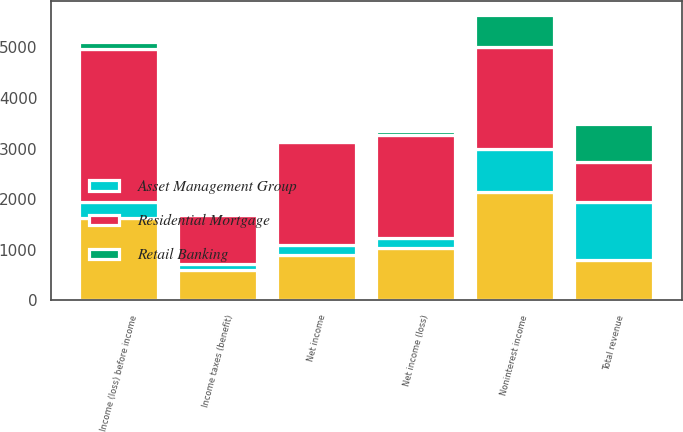Convert chart to OTSL. <chart><loc_0><loc_0><loc_500><loc_500><stacked_bar_chart><ecel><fcel>Noninterest income<fcel>Total revenue<fcel>Income (loss) before income<fcel>Income taxes (benefit)<fcel>Net income (loss)<fcel>Net income<nl><fcel>nan<fcel>2142<fcel>795.5<fcel>1620<fcel>593<fcel>1027<fcel>907<nl><fcel>Residential Mortgage<fcel>2006<fcel>795.5<fcel>3017<fcel>982<fcel>2035<fcel>2031<nl><fcel>Asset Management Group<fcel>851<fcel>1151<fcel>332<fcel>122<fcel>210<fcel>194<nl><fcel>Retail Banking<fcel>633<fcel>740<fcel>134<fcel>49<fcel>85<fcel>26<nl></chart> 